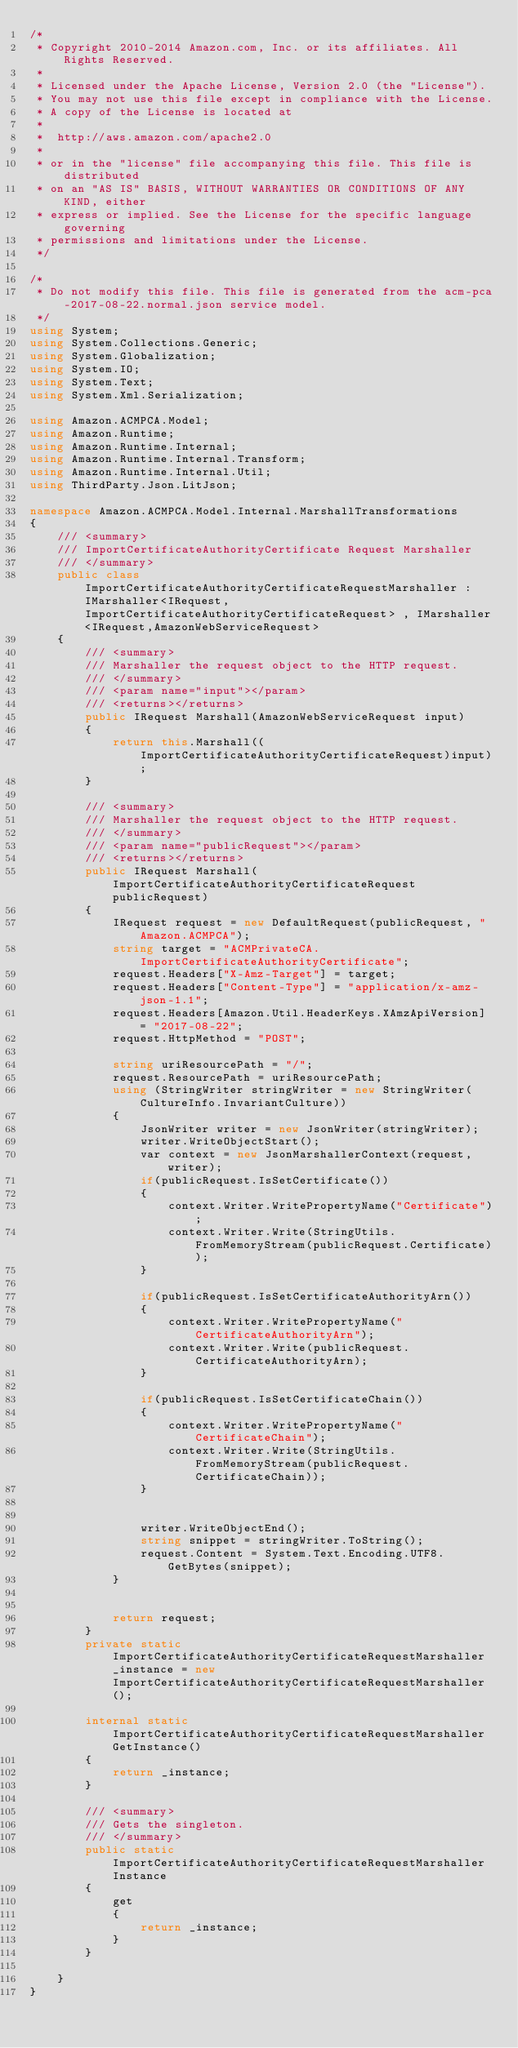Convert code to text. <code><loc_0><loc_0><loc_500><loc_500><_C#_>/*
 * Copyright 2010-2014 Amazon.com, Inc. or its affiliates. All Rights Reserved.
 * 
 * Licensed under the Apache License, Version 2.0 (the "License").
 * You may not use this file except in compliance with the License.
 * A copy of the License is located at
 * 
 *  http://aws.amazon.com/apache2.0
 * 
 * or in the "license" file accompanying this file. This file is distributed
 * on an "AS IS" BASIS, WITHOUT WARRANTIES OR CONDITIONS OF ANY KIND, either
 * express or implied. See the License for the specific language governing
 * permissions and limitations under the License.
 */

/*
 * Do not modify this file. This file is generated from the acm-pca-2017-08-22.normal.json service model.
 */
using System;
using System.Collections.Generic;
using System.Globalization;
using System.IO;
using System.Text;
using System.Xml.Serialization;

using Amazon.ACMPCA.Model;
using Amazon.Runtime;
using Amazon.Runtime.Internal;
using Amazon.Runtime.Internal.Transform;
using Amazon.Runtime.Internal.Util;
using ThirdParty.Json.LitJson;

namespace Amazon.ACMPCA.Model.Internal.MarshallTransformations
{
    /// <summary>
    /// ImportCertificateAuthorityCertificate Request Marshaller
    /// </summary>       
    public class ImportCertificateAuthorityCertificateRequestMarshaller : IMarshaller<IRequest, ImportCertificateAuthorityCertificateRequest> , IMarshaller<IRequest,AmazonWebServiceRequest>
    {
        /// <summary>
        /// Marshaller the request object to the HTTP request.
        /// </summary>  
        /// <param name="input"></param>
        /// <returns></returns>
        public IRequest Marshall(AmazonWebServiceRequest input)
        {
            return this.Marshall((ImportCertificateAuthorityCertificateRequest)input);
        }

        /// <summary>
        /// Marshaller the request object to the HTTP request.
        /// </summary>  
        /// <param name="publicRequest"></param>
        /// <returns></returns>
        public IRequest Marshall(ImportCertificateAuthorityCertificateRequest publicRequest)
        {
            IRequest request = new DefaultRequest(publicRequest, "Amazon.ACMPCA");
            string target = "ACMPrivateCA.ImportCertificateAuthorityCertificate";
            request.Headers["X-Amz-Target"] = target;
            request.Headers["Content-Type"] = "application/x-amz-json-1.1";
            request.Headers[Amazon.Util.HeaderKeys.XAmzApiVersion] = "2017-08-22";            
            request.HttpMethod = "POST";

            string uriResourcePath = "/";
            request.ResourcePath = uriResourcePath;
            using (StringWriter stringWriter = new StringWriter(CultureInfo.InvariantCulture))
            {
                JsonWriter writer = new JsonWriter(stringWriter);
                writer.WriteObjectStart();
                var context = new JsonMarshallerContext(request, writer);
                if(publicRequest.IsSetCertificate())
                {
                    context.Writer.WritePropertyName("Certificate");
                    context.Writer.Write(StringUtils.FromMemoryStream(publicRequest.Certificate));
                }

                if(publicRequest.IsSetCertificateAuthorityArn())
                {
                    context.Writer.WritePropertyName("CertificateAuthorityArn");
                    context.Writer.Write(publicRequest.CertificateAuthorityArn);
                }

                if(publicRequest.IsSetCertificateChain())
                {
                    context.Writer.WritePropertyName("CertificateChain");
                    context.Writer.Write(StringUtils.FromMemoryStream(publicRequest.CertificateChain));
                }

        
                writer.WriteObjectEnd();
                string snippet = stringWriter.ToString();
                request.Content = System.Text.Encoding.UTF8.GetBytes(snippet);
            }


            return request;
        }
        private static ImportCertificateAuthorityCertificateRequestMarshaller _instance = new ImportCertificateAuthorityCertificateRequestMarshaller();        

        internal static ImportCertificateAuthorityCertificateRequestMarshaller GetInstance()
        {
            return _instance;
        }

        /// <summary>
        /// Gets the singleton.
        /// </summary>  
        public static ImportCertificateAuthorityCertificateRequestMarshaller Instance
        {
            get
            {
                return _instance;
            }
        }

    }
}</code> 